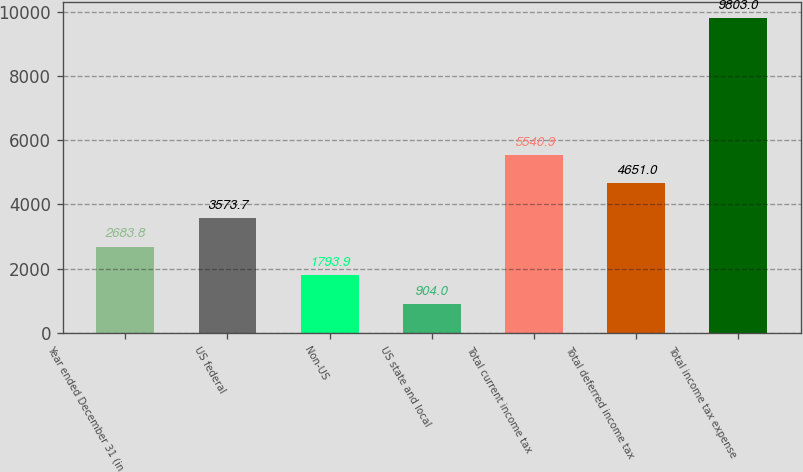<chart> <loc_0><loc_0><loc_500><loc_500><bar_chart><fcel>Year ended December 31 (in<fcel>US federal<fcel>Non-US<fcel>US state and local<fcel>Total current income tax<fcel>Total deferred income tax<fcel>Total income tax expense<nl><fcel>2683.8<fcel>3573.7<fcel>1793.9<fcel>904<fcel>5540.9<fcel>4651<fcel>9803<nl></chart> 